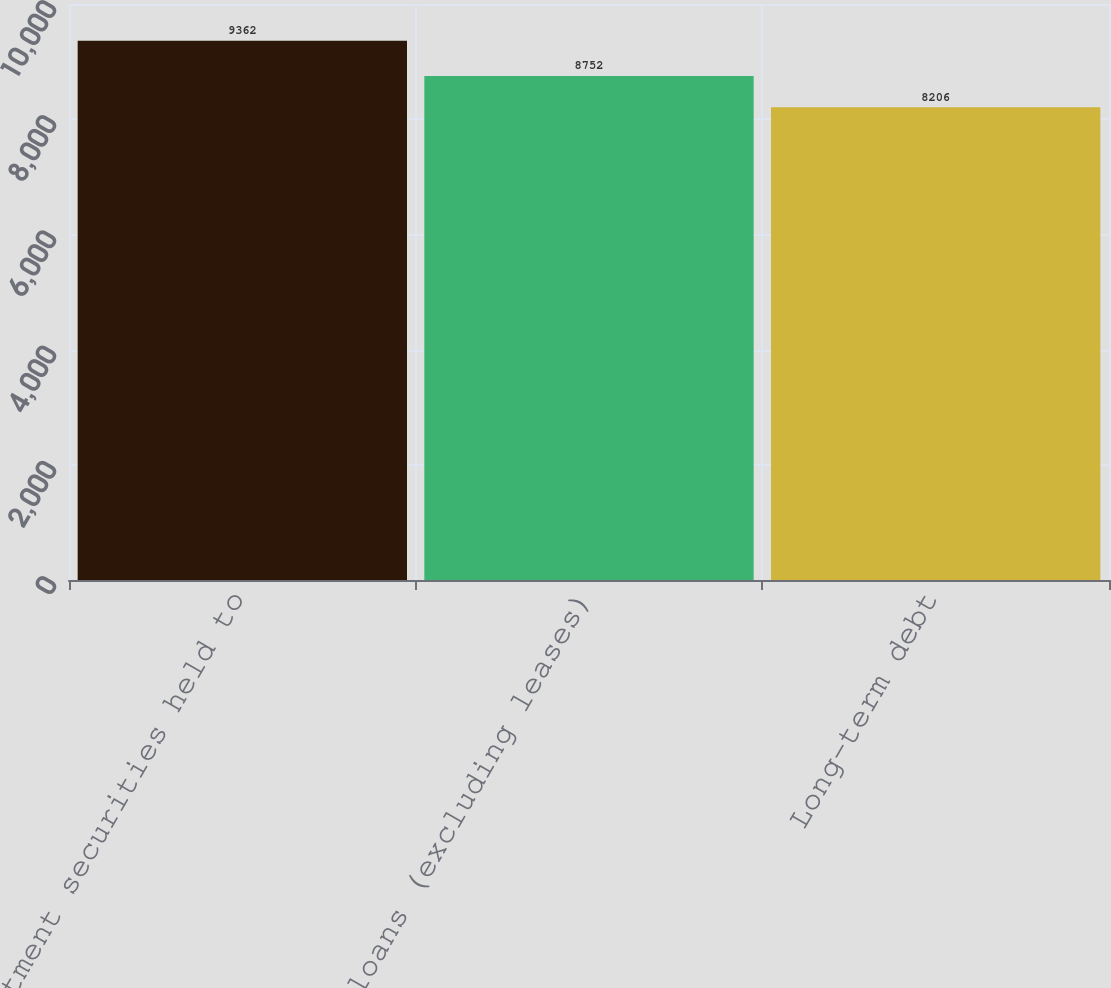Convert chart to OTSL. <chart><loc_0><loc_0><loc_500><loc_500><bar_chart><fcel>Investment securities held to<fcel>Net loans (excluding leases)<fcel>Long-term debt<nl><fcel>9362<fcel>8752<fcel>8206<nl></chart> 